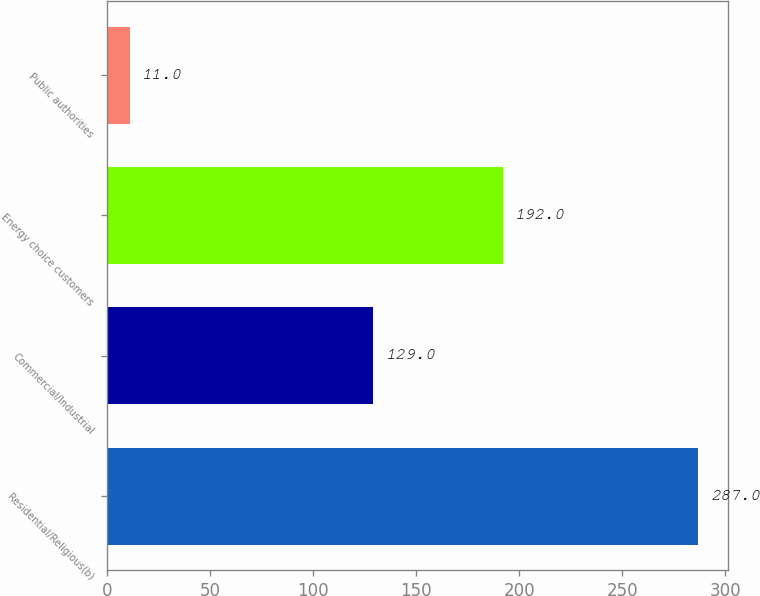Convert chart. <chart><loc_0><loc_0><loc_500><loc_500><bar_chart><fcel>Residential/Religious(b)<fcel>Commercial/Industrial<fcel>Energy choice customers<fcel>Public authorities<nl><fcel>287<fcel>129<fcel>192<fcel>11<nl></chart> 